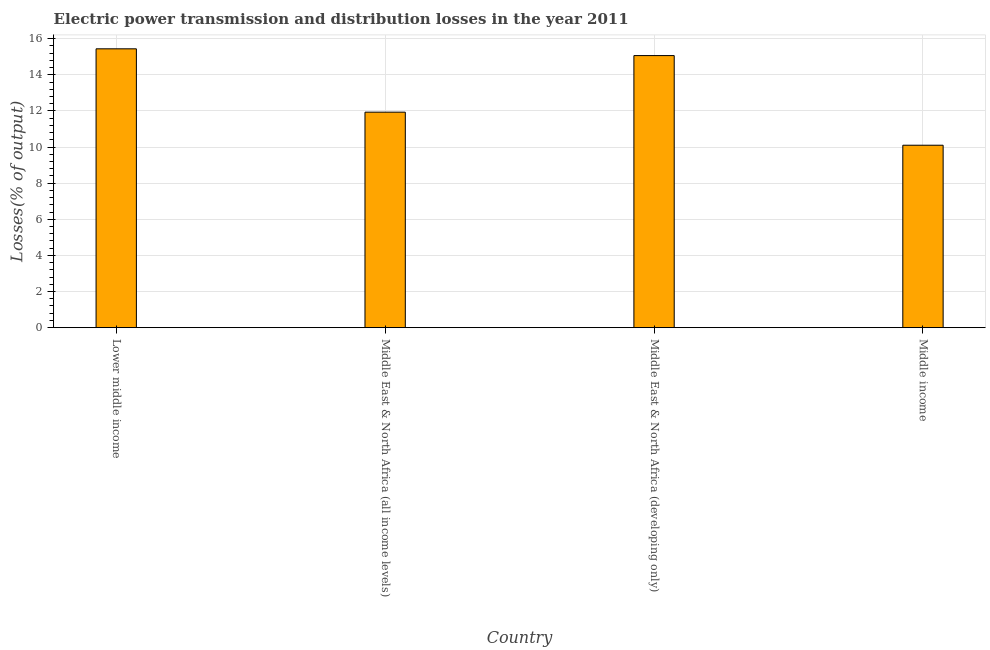What is the title of the graph?
Provide a succinct answer. Electric power transmission and distribution losses in the year 2011. What is the label or title of the Y-axis?
Your response must be concise. Losses(% of output). What is the electric power transmission and distribution losses in Middle East & North Africa (all income levels)?
Your answer should be compact. 11.93. Across all countries, what is the maximum electric power transmission and distribution losses?
Make the answer very short. 15.44. Across all countries, what is the minimum electric power transmission and distribution losses?
Keep it short and to the point. 10.1. In which country was the electric power transmission and distribution losses maximum?
Offer a very short reply. Lower middle income. In which country was the electric power transmission and distribution losses minimum?
Provide a succinct answer. Middle income. What is the sum of the electric power transmission and distribution losses?
Your answer should be compact. 52.55. What is the difference between the electric power transmission and distribution losses in Lower middle income and Middle East & North Africa (all income levels)?
Offer a very short reply. 3.51. What is the average electric power transmission and distribution losses per country?
Make the answer very short. 13.14. What is the median electric power transmission and distribution losses?
Offer a very short reply. 13.5. In how many countries, is the electric power transmission and distribution losses greater than 6 %?
Make the answer very short. 4. What is the ratio of the electric power transmission and distribution losses in Middle East & North Africa (all income levels) to that in Middle income?
Your answer should be compact. 1.18. Is the electric power transmission and distribution losses in Middle East & North Africa (all income levels) less than that in Middle East & North Africa (developing only)?
Your answer should be very brief. Yes. What is the difference between the highest and the second highest electric power transmission and distribution losses?
Your answer should be very brief. 0.37. What is the difference between the highest and the lowest electric power transmission and distribution losses?
Provide a succinct answer. 5.34. Are all the bars in the graph horizontal?
Provide a short and direct response. No. How many countries are there in the graph?
Ensure brevity in your answer.  4. Are the values on the major ticks of Y-axis written in scientific E-notation?
Make the answer very short. No. What is the Losses(% of output) of Lower middle income?
Keep it short and to the point. 15.44. What is the Losses(% of output) in Middle East & North Africa (all income levels)?
Provide a succinct answer. 11.93. What is the Losses(% of output) of Middle East & North Africa (developing only)?
Offer a very short reply. 15.07. What is the Losses(% of output) of Middle income?
Give a very brief answer. 10.1. What is the difference between the Losses(% of output) in Lower middle income and Middle East & North Africa (all income levels)?
Give a very brief answer. 3.51. What is the difference between the Losses(% of output) in Lower middle income and Middle East & North Africa (developing only)?
Provide a short and direct response. 0.37. What is the difference between the Losses(% of output) in Lower middle income and Middle income?
Offer a terse response. 5.34. What is the difference between the Losses(% of output) in Middle East & North Africa (all income levels) and Middle East & North Africa (developing only)?
Keep it short and to the point. -3.13. What is the difference between the Losses(% of output) in Middle East & North Africa (all income levels) and Middle income?
Your answer should be compact. 1.83. What is the difference between the Losses(% of output) in Middle East & North Africa (developing only) and Middle income?
Give a very brief answer. 4.96. What is the ratio of the Losses(% of output) in Lower middle income to that in Middle East & North Africa (all income levels)?
Ensure brevity in your answer.  1.29. What is the ratio of the Losses(% of output) in Lower middle income to that in Middle income?
Make the answer very short. 1.53. What is the ratio of the Losses(% of output) in Middle East & North Africa (all income levels) to that in Middle East & North Africa (developing only)?
Make the answer very short. 0.79. What is the ratio of the Losses(% of output) in Middle East & North Africa (all income levels) to that in Middle income?
Your answer should be very brief. 1.18. What is the ratio of the Losses(% of output) in Middle East & North Africa (developing only) to that in Middle income?
Your response must be concise. 1.49. 